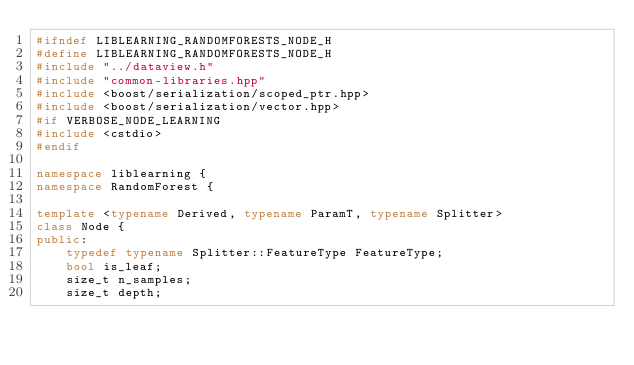<code> <loc_0><loc_0><loc_500><loc_500><_C++_>#ifndef LIBLEARNING_RANDOMFORESTS_NODE_H
#define LIBLEARNING_RANDOMFORESTS_NODE_H 
#include "../dataview.h"
#include "common-libraries.hpp"
#include <boost/serialization/scoped_ptr.hpp>
#include <boost/serialization/vector.hpp>
#if VERBOSE_NODE_LEARNING
#include <cstdio>
#endif

namespace liblearning {
namespace RandomForest {

template <typename Derived, typename ParamT, typename Splitter>
class Node {
public:
    typedef typename Splitter::FeatureType FeatureType;
    bool is_leaf;
    size_t n_samples;
    size_t depth;</code> 